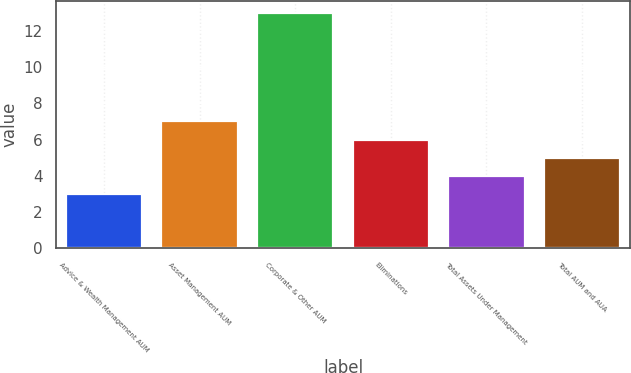Convert chart. <chart><loc_0><loc_0><loc_500><loc_500><bar_chart><fcel>Advice & Wealth Management AUM<fcel>Asset Management AUM<fcel>Corporate & Other AUM<fcel>Eliminations<fcel>Total Assets Under Management<fcel>Total AUM and AUA<nl><fcel>3<fcel>7<fcel>13<fcel>6<fcel>4<fcel>5<nl></chart> 